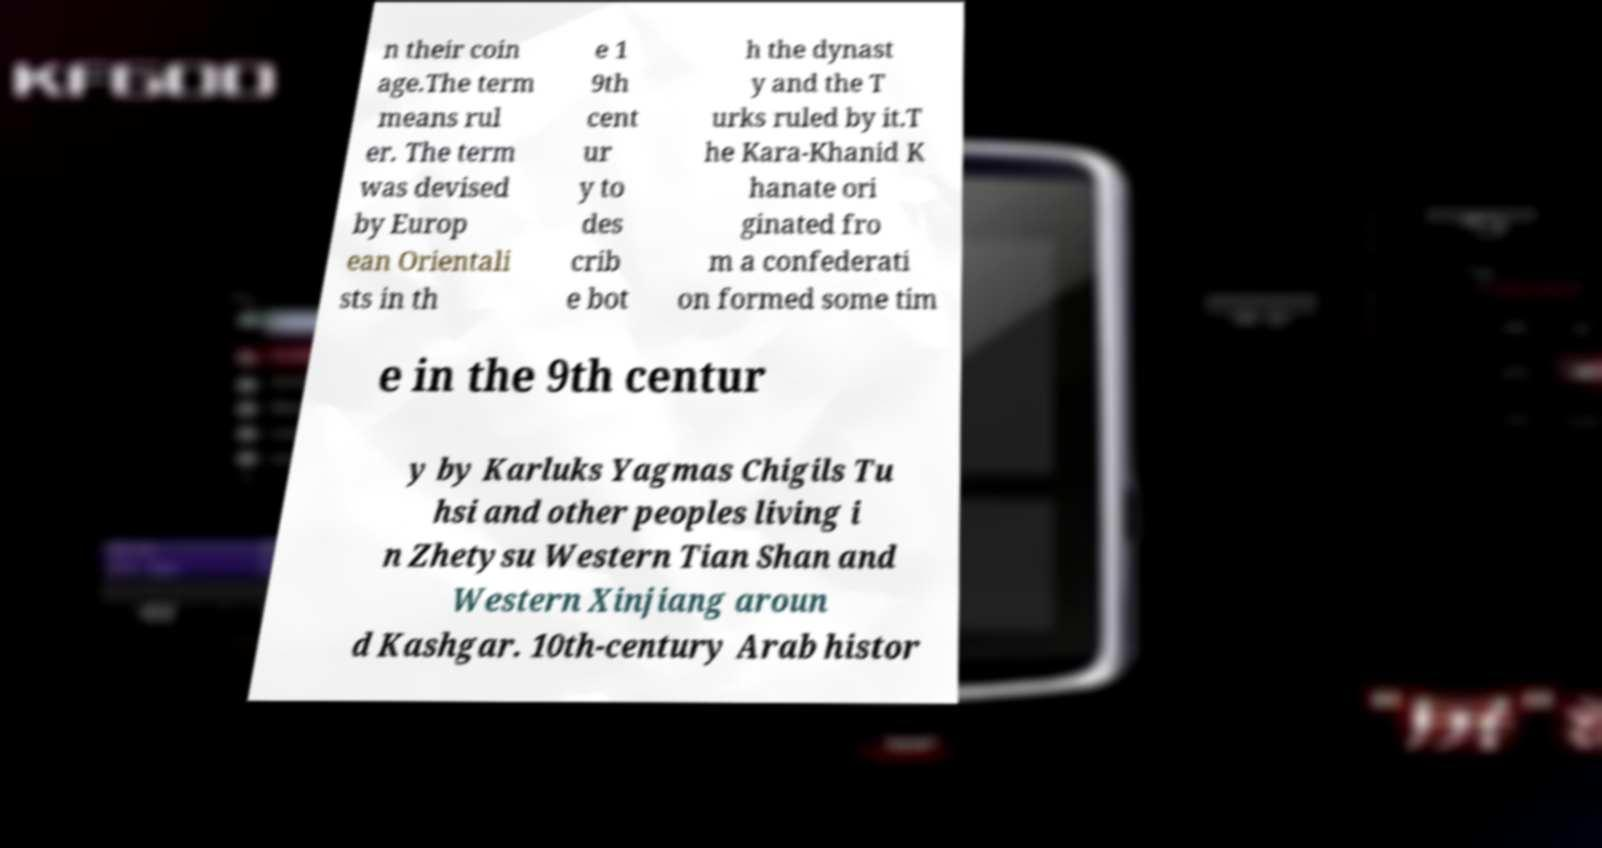What messages or text are displayed in this image? I need them in a readable, typed format. n their coin age.The term means rul er. The term was devised by Europ ean Orientali sts in th e 1 9th cent ur y to des crib e bot h the dynast y and the T urks ruled by it.T he Kara-Khanid K hanate ori ginated fro m a confederati on formed some tim e in the 9th centur y by Karluks Yagmas Chigils Tu hsi and other peoples living i n Zhetysu Western Tian Shan and Western Xinjiang aroun d Kashgar. 10th-century Arab histor 